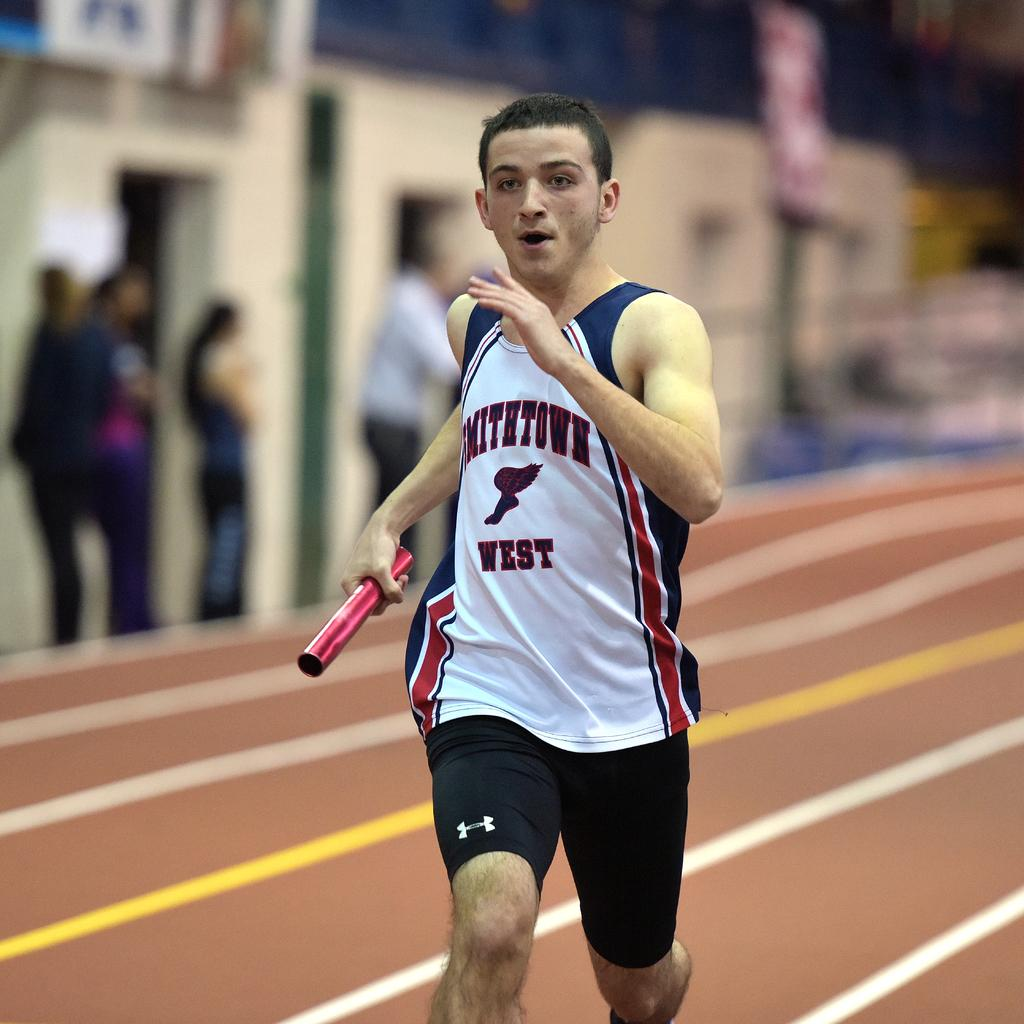<image>
Summarize the visual content of the image. A man running and holding a baton; the word West is on his shirt. 